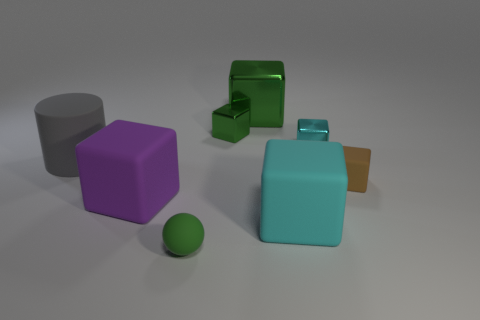Subtract all brown blocks. How many blocks are left? 5 Subtract all small matte blocks. How many blocks are left? 5 Subtract all yellow blocks. Subtract all blue spheres. How many blocks are left? 6 Add 2 big blue metallic things. How many objects exist? 10 Subtract all cubes. How many objects are left? 2 Add 5 tiny cyan metallic blocks. How many tiny cyan metallic blocks exist? 6 Subtract 1 gray cylinders. How many objects are left? 7 Subtract all green metallic objects. Subtract all gray cylinders. How many objects are left? 5 Add 5 large metal cubes. How many large metal cubes are left? 6 